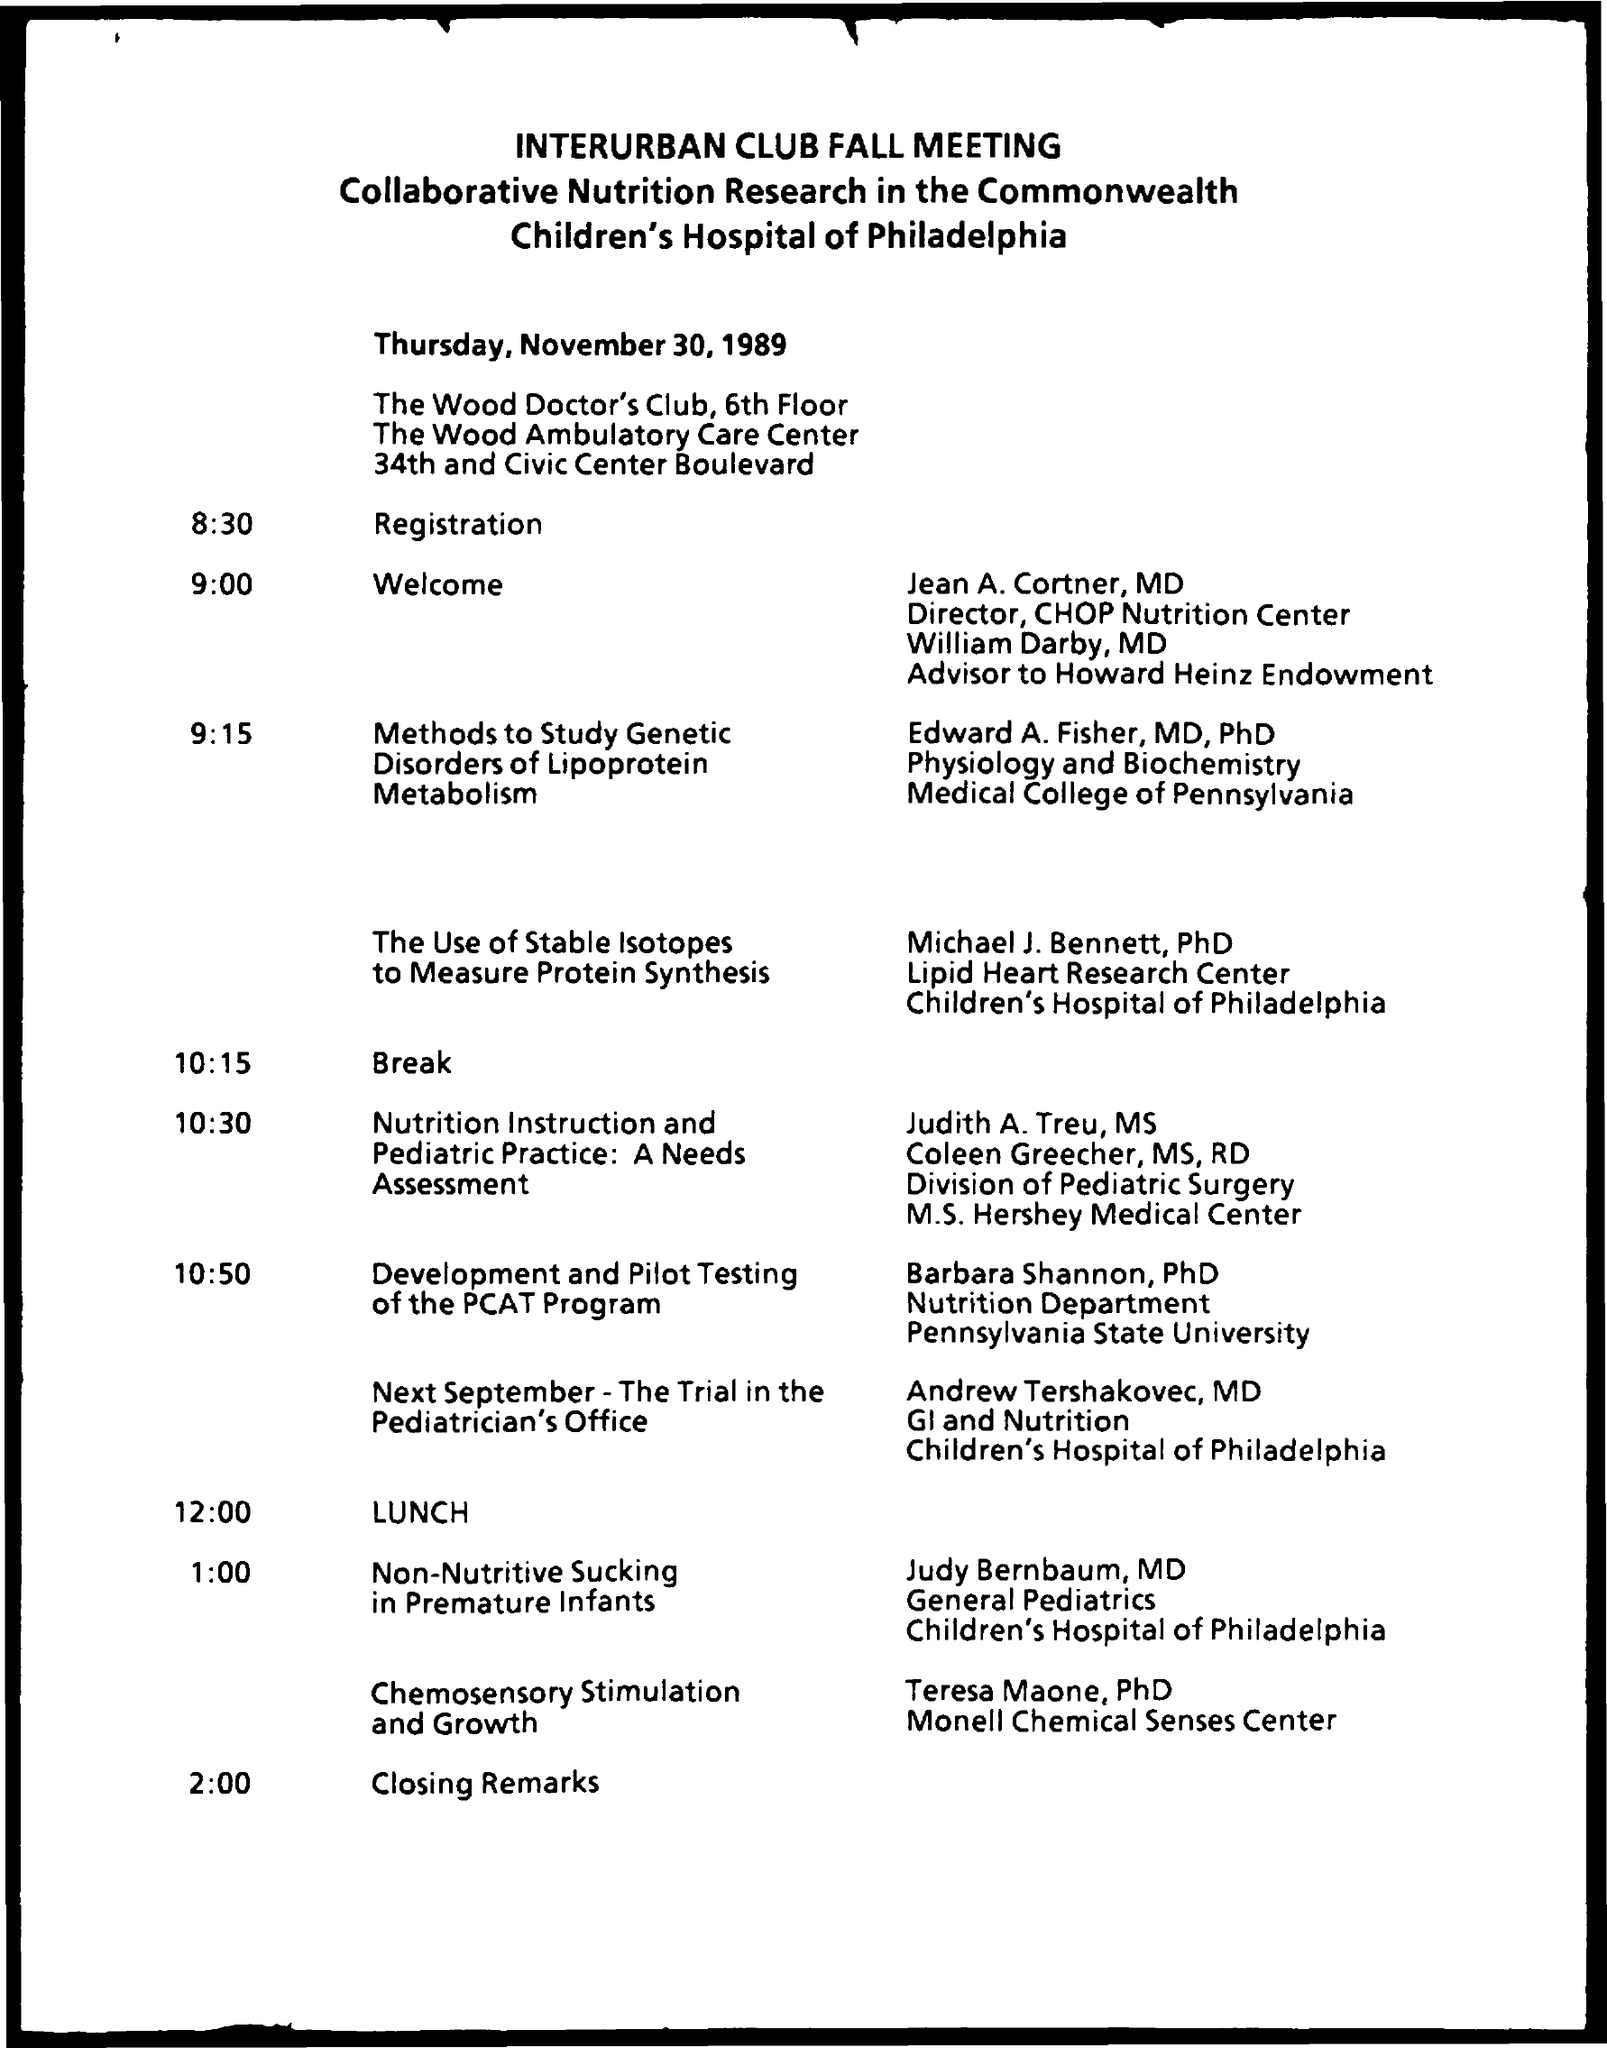Can you tell me more about the event and its focus? The image shows a schedule for the Interurban Club Fall Meeting focused on Collaborative Nutrition Research in the Commonwealth at the Children's Hospital of Philadelphia on Thursday, November 30, 1989. The event features presentations on a variety of topics related to nutrition and pediatric healthcare.  Who was speaking right before lunchtime? Right before lunch at 10:50 AM, the schedule indicates a presentation titled 'Development and Pilot Testing of the PCAT Program' by Barbara Shannon, PhD of the Nutrition Department at Pennsylvania State University. 